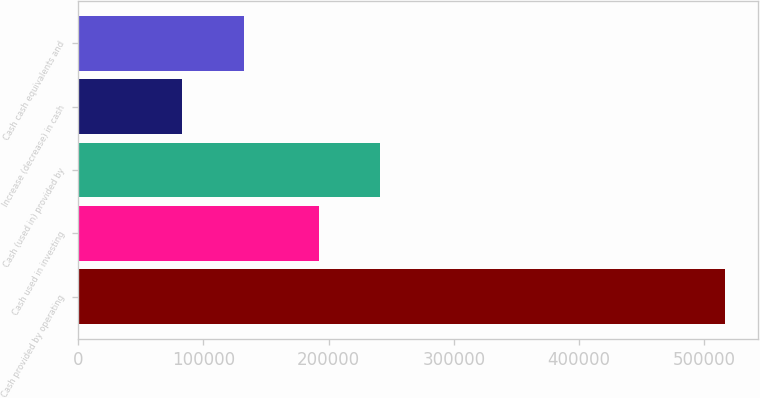Convert chart to OTSL. <chart><loc_0><loc_0><loc_500><loc_500><bar_chart><fcel>Cash provided by operating<fcel>Cash used in investing<fcel>Cash (used in) provided by<fcel>Increase (decrease) in cash<fcel>Cash cash equivalents and<nl><fcel>516688<fcel>192247<fcel>241396<fcel>83132<fcel>132281<nl></chart> 